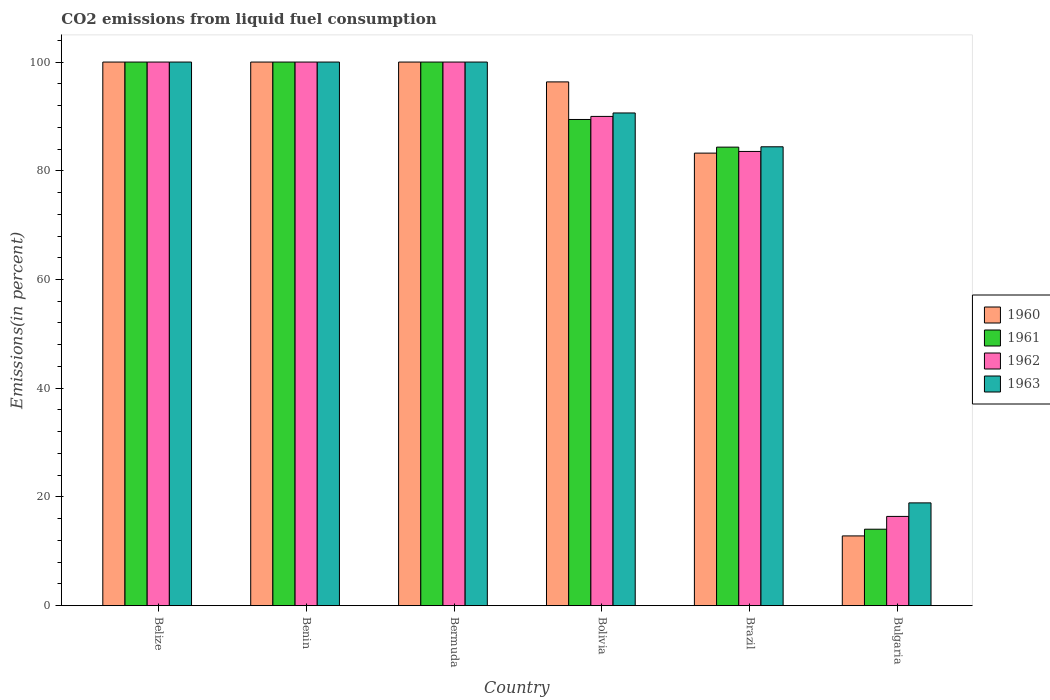How many groups of bars are there?
Keep it short and to the point. 6. Are the number of bars per tick equal to the number of legend labels?
Your answer should be very brief. Yes. Are the number of bars on each tick of the X-axis equal?
Ensure brevity in your answer.  Yes. How many bars are there on the 3rd tick from the left?
Make the answer very short. 4. In how many cases, is the number of bars for a given country not equal to the number of legend labels?
Your answer should be very brief. 0. What is the total CO2 emitted in 1960 in Bermuda?
Provide a succinct answer. 100. Across all countries, what is the minimum total CO2 emitted in 1960?
Ensure brevity in your answer.  12.83. In which country was the total CO2 emitted in 1962 maximum?
Provide a short and direct response. Belize. In which country was the total CO2 emitted in 1962 minimum?
Your answer should be compact. Bulgaria. What is the total total CO2 emitted in 1961 in the graph?
Your answer should be compact. 487.85. What is the difference between the total CO2 emitted in 1962 in Brazil and that in Bulgaria?
Ensure brevity in your answer.  67.14. What is the difference between the total CO2 emitted in 1961 in Bolivia and the total CO2 emitted in 1960 in Bermuda?
Give a very brief answer. -10.56. What is the average total CO2 emitted in 1962 per country?
Your answer should be compact. 81.66. What is the difference between the total CO2 emitted of/in 1963 and total CO2 emitted of/in 1960 in Brazil?
Your answer should be compact. 1.17. What is the ratio of the total CO2 emitted in 1960 in Benin to that in Bolivia?
Offer a terse response. 1.04. What is the difference between the highest and the lowest total CO2 emitted in 1962?
Give a very brief answer. 83.58. In how many countries, is the total CO2 emitted in 1963 greater than the average total CO2 emitted in 1963 taken over all countries?
Your response must be concise. 5. Is the sum of the total CO2 emitted in 1963 in Bolivia and Bulgaria greater than the maximum total CO2 emitted in 1960 across all countries?
Ensure brevity in your answer.  Yes. Is it the case that in every country, the sum of the total CO2 emitted in 1960 and total CO2 emitted in 1961 is greater than the sum of total CO2 emitted in 1963 and total CO2 emitted in 1962?
Offer a terse response. No. How many bars are there?
Provide a short and direct response. 24. Are the values on the major ticks of Y-axis written in scientific E-notation?
Make the answer very short. No. Does the graph contain any zero values?
Your answer should be very brief. No. Does the graph contain grids?
Provide a short and direct response. No. Where does the legend appear in the graph?
Give a very brief answer. Center right. How are the legend labels stacked?
Give a very brief answer. Vertical. What is the title of the graph?
Provide a short and direct response. CO2 emissions from liquid fuel consumption. Does "1985" appear as one of the legend labels in the graph?
Give a very brief answer. No. What is the label or title of the Y-axis?
Your answer should be very brief. Emissions(in percent). What is the Emissions(in percent) of 1961 in Belize?
Give a very brief answer. 100. What is the Emissions(in percent) of 1963 in Benin?
Your answer should be compact. 100. What is the Emissions(in percent) in 1960 in Bolivia?
Provide a succinct answer. 96.35. What is the Emissions(in percent) in 1961 in Bolivia?
Offer a terse response. 89.44. What is the Emissions(in percent) of 1963 in Bolivia?
Make the answer very short. 90.63. What is the Emissions(in percent) in 1960 in Brazil?
Keep it short and to the point. 83.25. What is the Emissions(in percent) of 1961 in Brazil?
Make the answer very short. 84.35. What is the Emissions(in percent) in 1962 in Brazil?
Your response must be concise. 83.56. What is the Emissions(in percent) of 1963 in Brazil?
Make the answer very short. 84.41. What is the Emissions(in percent) of 1960 in Bulgaria?
Give a very brief answer. 12.83. What is the Emissions(in percent) in 1961 in Bulgaria?
Offer a terse response. 14.06. What is the Emissions(in percent) of 1962 in Bulgaria?
Provide a succinct answer. 16.42. What is the Emissions(in percent) in 1963 in Bulgaria?
Keep it short and to the point. 18.9. Across all countries, what is the maximum Emissions(in percent) of 1960?
Your response must be concise. 100. Across all countries, what is the maximum Emissions(in percent) in 1961?
Your answer should be very brief. 100. Across all countries, what is the maximum Emissions(in percent) in 1963?
Your answer should be very brief. 100. Across all countries, what is the minimum Emissions(in percent) of 1960?
Your response must be concise. 12.83. Across all countries, what is the minimum Emissions(in percent) in 1961?
Provide a succinct answer. 14.06. Across all countries, what is the minimum Emissions(in percent) of 1962?
Your answer should be very brief. 16.42. Across all countries, what is the minimum Emissions(in percent) of 1963?
Offer a terse response. 18.9. What is the total Emissions(in percent) of 1960 in the graph?
Give a very brief answer. 492.43. What is the total Emissions(in percent) of 1961 in the graph?
Give a very brief answer. 487.85. What is the total Emissions(in percent) of 1962 in the graph?
Give a very brief answer. 489.97. What is the total Emissions(in percent) in 1963 in the graph?
Give a very brief answer. 493.95. What is the difference between the Emissions(in percent) in 1960 in Belize and that in Benin?
Your answer should be compact. 0. What is the difference between the Emissions(in percent) of 1961 in Belize and that in Benin?
Provide a succinct answer. 0. What is the difference between the Emissions(in percent) of 1962 in Belize and that in Benin?
Your answer should be very brief. 0. What is the difference between the Emissions(in percent) in 1963 in Belize and that in Benin?
Give a very brief answer. 0. What is the difference between the Emissions(in percent) in 1961 in Belize and that in Bermuda?
Your response must be concise. 0. What is the difference between the Emissions(in percent) in 1963 in Belize and that in Bermuda?
Provide a short and direct response. 0. What is the difference between the Emissions(in percent) in 1960 in Belize and that in Bolivia?
Provide a succinct answer. 3.65. What is the difference between the Emissions(in percent) of 1961 in Belize and that in Bolivia?
Offer a very short reply. 10.56. What is the difference between the Emissions(in percent) in 1962 in Belize and that in Bolivia?
Offer a very short reply. 10. What is the difference between the Emissions(in percent) of 1963 in Belize and that in Bolivia?
Provide a short and direct response. 9.37. What is the difference between the Emissions(in percent) in 1960 in Belize and that in Brazil?
Offer a terse response. 16.75. What is the difference between the Emissions(in percent) of 1961 in Belize and that in Brazil?
Your response must be concise. 15.65. What is the difference between the Emissions(in percent) in 1962 in Belize and that in Brazil?
Provide a short and direct response. 16.44. What is the difference between the Emissions(in percent) of 1963 in Belize and that in Brazil?
Your answer should be compact. 15.59. What is the difference between the Emissions(in percent) of 1960 in Belize and that in Bulgaria?
Offer a terse response. 87.17. What is the difference between the Emissions(in percent) of 1961 in Belize and that in Bulgaria?
Make the answer very short. 85.94. What is the difference between the Emissions(in percent) in 1962 in Belize and that in Bulgaria?
Your answer should be compact. 83.58. What is the difference between the Emissions(in percent) of 1963 in Belize and that in Bulgaria?
Make the answer very short. 81.1. What is the difference between the Emissions(in percent) of 1960 in Benin and that in Bolivia?
Provide a short and direct response. 3.65. What is the difference between the Emissions(in percent) of 1961 in Benin and that in Bolivia?
Keep it short and to the point. 10.56. What is the difference between the Emissions(in percent) of 1963 in Benin and that in Bolivia?
Your response must be concise. 9.37. What is the difference between the Emissions(in percent) of 1960 in Benin and that in Brazil?
Provide a succinct answer. 16.75. What is the difference between the Emissions(in percent) in 1961 in Benin and that in Brazil?
Offer a terse response. 15.65. What is the difference between the Emissions(in percent) of 1962 in Benin and that in Brazil?
Provide a succinct answer. 16.44. What is the difference between the Emissions(in percent) in 1963 in Benin and that in Brazil?
Ensure brevity in your answer.  15.59. What is the difference between the Emissions(in percent) of 1960 in Benin and that in Bulgaria?
Give a very brief answer. 87.17. What is the difference between the Emissions(in percent) of 1961 in Benin and that in Bulgaria?
Give a very brief answer. 85.94. What is the difference between the Emissions(in percent) of 1962 in Benin and that in Bulgaria?
Your answer should be compact. 83.58. What is the difference between the Emissions(in percent) of 1963 in Benin and that in Bulgaria?
Your answer should be very brief. 81.1. What is the difference between the Emissions(in percent) of 1960 in Bermuda and that in Bolivia?
Your answer should be very brief. 3.65. What is the difference between the Emissions(in percent) in 1961 in Bermuda and that in Bolivia?
Your answer should be compact. 10.56. What is the difference between the Emissions(in percent) in 1963 in Bermuda and that in Bolivia?
Provide a succinct answer. 9.37. What is the difference between the Emissions(in percent) in 1960 in Bermuda and that in Brazil?
Your answer should be compact. 16.75. What is the difference between the Emissions(in percent) in 1961 in Bermuda and that in Brazil?
Your answer should be compact. 15.65. What is the difference between the Emissions(in percent) of 1962 in Bermuda and that in Brazil?
Offer a very short reply. 16.44. What is the difference between the Emissions(in percent) of 1963 in Bermuda and that in Brazil?
Offer a very short reply. 15.59. What is the difference between the Emissions(in percent) of 1960 in Bermuda and that in Bulgaria?
Make the answer very short. 87.17. What is the difference between the Emissions(in percent) in 1961 in Bermuda and that in Bulgaria?
Provide a succinct answer. 85.94. What is the difference between the Emissions(in percent) of 1962 in Bermuda and that in Bulgaria?
Offer a very short reply. 83.58. What is the difference between the Emissions(in percent) of 1963 in Bermuda and that in Bulgaria?
Keep it short and to the point. 81.1. What is the difference between the Emissions(in percent) in 1960 in Bolivia and that in Brazil?
Offer a very short reply. 13.1. What is the difference between the Emissions(in percent) in 1961 in Bolivia and that in Brazil?
Provide a succinct answer. 5.09. What is the difference between the Emissions(in percent) of 1962 in Bolivia and that in Brazil?
Offer a very short reply. 6.44. What is the difference between the Emissions(in percent) of 1963 in Bolivia and that in Brazil?
Make the answer very short. 6.22. What is the difference between the Emissions(in percent) in 1960 in Bolivia and that in Bulgaria?
Give a very brief answer. 83.52. What is the difference between the Emissions(in percent) of 1961 in Bolivia and that in Bulgaria?
Keep it short and to the point. 75.37. What is the difference between the Emissions(in percent) of 1962 in Bolivia and that in Bulgaria?
Your answer should be very brief. 73.58. What is the difference between the Emissions(in percent) in 1963 in Bolivia and that in Bulgaria?
Ensure brevity in your answer.  71.73. What is the difference between the Emissions(in percent) of 1960 in Brazil and that in Bulgaria?
Make the answer very short. 70.42. What is the difference between the Emissions(in percent) of 1961 in Brazil and that in Bulgaria?
Your answer should be compact. 70.29. What is the difference between the Emissions(in percent) in 1962 in Brazil and that in Bulgaria?
Your answer should be very brief. 67.14. What is the difference between the Emissions(in percent) of 1963 in Brazil and that in Bulgaria?
Provide a short and direct response. 65.51. What is the difference between the Emissions(in percent) of 1960 in Belize and the Emissions(in percent) of 1962 in Benin?
Offer a terse response. 0. What is the difference between the Emissions(in percent) of 1960 in Belize and the Emissions(in percent) of 1963 in Benin?
Your response must be concise. 0. What is the difference between the Emissions(in percent) of 1962 in Belize and the Emissions(in percent) of 1963 in Benin?
Offer a very short reply. 0. What is the difference between the Emissions(in percent) of 1960 in Belize and the Emissions(in percent) of 1963 in Bermuda?
Your response must be concise. 0. What is the difference between the Emissions(in percent) of 1961 in Belize and the Emissions(in percent) of 1963 in Bermuda?
Offer a very short reply. 0. What is the difference between the Emissions(in percent) in 1962 in Belize and the Emissions(in percent) in 1963 in Bermuda?
Your answer should be very brief. 0. What is the difference between the Emissions(in percent) in 1960 in Belize and the Emissions(in percent) in 1961 in Bolivia?
Your response must be concise. 10.56. What is the difference between the Emissions(in percent) of 1960 in Belize and the Emissions(in percent) of 1963 in Bolivia?
Offer a terse response. 9.37. What is the difference between the Emissions(in percent) of 1961 in Belize and the Emissions(in percent) of 1963 in Bolivia?
Ensure brevity in your answer.  9.37. What is the difference between the Emissions(in percent) of 1962 in Belize and the Emissions(in percent) of 1963 in Bolivia?
Make the answer very short. 9.37. What is the difference between the Emissions(in percent) of 1960 in Belize and the Emissions(in percent) of 1961 in Brazil?
Offer a very short reply. 15.65. What is the difference between the Emissions(in percent) of 1960 in Belize and the Emissions(in percent) of 1962 in Brazil?
Your answer should be very brief. 16.44. What is the difference between the Emissions(in percent) in 1960 in Belize and the Emissions(in percent) in 1963 in Brazil?
Provide a short and direct response. 15.59. What is the difference between the Emissions(in percent) of 1961 in Belize and the Emissions(in percent) of 1962 in Brazil?
Make the answer very short. 16.44. What is the difference between the Emissions(in percent) in 1961 in Belize and the Emissions(in percent) in 1963 in Brazil?
Keep it short and to the point. 15.59. What is the difference between the Emissions(in percent) in 1962 in Belize and the Emissions(in percent) in 1963 in Brazil?
Your answer should be compact. 15.59. What is the difference between the Emissions(in percent) of 1960 in Belize and the Emissions(in percent) of 1961 in Bulgaria?
Give a very brief answer. 85.94. What is the difference between the Emissions(in percent) in 1960 in Belize and the Emissions(in percent) in 1962 in Bulgaria?
Make the answer very short. 83.58. What is the difference between the Emissions(in percent) in 1960 in Belize and the Emissions(in percent) in 1963 in Bulgaria?
Provide a succinct answer. 81.1. What is the difference between the Emissions(in percent) in 1961 in Belize and the Emissions(in percent) in 1962 in Bulgaria?
Ensure brevity in your answer.  83.58. What is the difference between the Emissions(in percent) of 1961 in Belize and the Emissions(in percent) of 1963 in Bulgaria?
Provide a short and direct response. 81.1. What is the difference between the Emissions(in percent) of 1962 in Belize and the Emissions(in percent) of 1963 in Bulgaria?
Your answer should be very brief. 81.1. What is the difference between the Emissions(in percent) in 1960 in Benin and the Emissions(in percent) in 1961 in Bermuda?
Your answer should be very brief. 0. What is the difference between the Emissions(in percent) in 1960 in Benin and the Emissions(in percent) in 1962 in Bermuda?
Your response must be concise. 0. What is the difference between the Emissions(in percent) in 1960 in Benin and the Emissions(in percent) in 1963 in Bermuda?
Offer a very short reply. 0. What is the difference between the Emissions(in percent) of 1961 in Benin and the Emissions(in percent) of 1963 in Bermuda?
Keep it short and to the point. 0. What is the difference between the Emissions(in percent) in 1960 in Benin and the Emissions(in percent) in 1961 in Bolivia?
Provide a short and direct response. 10.56. What is the difference between the Emissions(in percent) in 1960 in Benin and the Emissions(in percent) in 1963 in Bolivia?
Give a very brief answer. 9.37. What is the difference between the Emissions(in percent) of 1961 in Benin and the Emissions(in percent) of 1962 in Bolivia?
Provide a short and direct response. 10. What is the difference between the Emissions(in percent) in 1961 in Benin and the Emissions(in percent) in 1963 in Bolivia?
Give a very brief answer. 9.37. What is the difference between the Emissions(in percent) in 1962 in Benin and the Emissions(in percent) in 1963 in Bolivia?
Offer a very short reply. 9.37. What is the difference between the Emissions(in percent) in 1960 in Benin and the Emissions(in percent) in 1961 in Brazil?
Your answer should be very brief. 15.65. What is the difference between the Emissions(in percent) of 1960 in Benin and the Emissions(in percent) of 1962 in Brazil?
Make the answer very short. 16.44. What is the difference between the Emissions(in percent) of 1960 in Benin and the Emissions(in percent) of 1963 in Brazil?
Offer a terse response. 15.59. What is the difference between the Emissions(in percent) in 1961 in Benin and the Emissions(in percent) in 1962 in Brazil?
Give a very brief answer. 16.44. What is the difference between the Emissions(in percent) of 1961 in Benin and the Emissions(in percent) of 1963 in Brazil?
Provide a short and direct response. 15.59. What is the difference between the Emissions(in percent) in 1962 in Benin and the Emissions(in percent) in 1963 in Brazil?
Your response must be concise. 15.59. What is the difference between the Emissions(in percent) in 1960 in Benin and the Emissions(in percent) in 1961 in Bulgaria?
Ensure brevity in your answer.  85.94. What is the difference between the Emissions(in percent) in 1960 in Benin and the Emissions(in percent) in 1962 in Bulgaria?
Your response must be concise. 83.58. What is the difference between the Emissions(in percent) in 1960 in Benin and the Emissions(in percent) in 1963 in Bulgaria?
Your answer should be compact. 81.1. What is the difference between the Emissions(in percent) in 1961 in Benin and the Emissions(in percent) in 1962 in Bulgaria?
Keep it short and to the point. 83.58. What is the difference between the Emissions(in percent) of 1961 in Benin and the Emissions(in percent) of 1963 in Bulgaria?
Offer a terse response. 81.1. What is the difference between the Emissions(in percent) in 1962 in Benin and the Emissions(in percent) in 1963 in Bulgaria?
Provide a succinct answer. 81.1. What is the difference between the Emissions(in percent) of 1960 in Bermuda and the Emissions(in percent) of 1961 in Bolivia?
Provide a succinct answer. 10.56. What is the difference between the Emissions(in percent) of 1960 in Bermuda and the Emissions(in percent) of 1963 in Bolivia?
Ensure brevity in your answer.  9.37. What is the difference between the Emissions(in percent) of 1961 in Bermuda and the Emissions(in percent) of 1963 in Bolivia?
Your answer should be compact. 9.37. What is the difference between the Emissions(in percent) of 1962 in Bermuda and the Emissions(in percent) of 1963 in Bolivia?
Your answer should be very brief. 9.37. What is the difference between the Emissions(in percent) of 1960 in Bermuda and the Emissions(in percent) of 1961 in Brazil?
Give a very brief answer. 15.65. What is the difference between the Emissions(in percent) of 1960 in Bermuda and the Emissions(in percent) of 1962 in Brazil?
Your response must be concise. 16.44. What is the difference between the Emissions(in percent) of 1960 in Bermuda and the Emissions(in percent) of 1963 in Brazil?
Ensure brevity in your answer.  15.59. What is the difference between the Emissions(in percent) in 1961 in Bermuda and the Emissions(in percent) in 1962 in Brazil?
Make the answer very short. 16.44. What is the difference between the Emissions(in percent) in 1961 in Bermuda and the Emissions(in percent) in 1963 in Brazil?
Your answer should be compact. 15.59. What is the difference between the Emissions(in percent) of 1962 in Bermuda and the Emissions(in percent) of 1963 in Brazil?
Offer a very short reply. 15.59. What is the difference between the Emissions(in percent) in 1960 in Bermuda and the Emissions(in percent) in 1961 in Bulgaria?
Provide a short and direct response. 85.94. What is the difference between the Emissions(in percent) in 1960 in Bermuda and the Emissions(in percent) in 1962 in Bulgaria?
Keep it short and to the point. 83.58. What is the difference between the Emissions(in percent) of 1960 in Bermuda and the Emissions(in percent) of 1963 in Bulgaria?
Provide a short and direct response. 81.1. What is the difference between the Emissions(in percent) of 1961 in Bermuda and the Emissions(in percent) of 1962 in Bulgaria?
Offer a very short reply. 83.58. What is the difference between the Emissions(in percent) in 1961 in Bermuda and the Emissions(in percent) in 1963 in Bulgaria?
Provide a short and direct response. 81.1. What is the difference between the Emissions(in percent) of 1962 in Bermuda and the Emissions(in percent) of 1963 in Bulgaria?
Offer a very short reply. 81.1. What is the difference between the Emissions(in percent) of 1960 in Bolivia and the Emissions(in percent) of 1961 in Brazil?
Provide a succinct answer. 12. What is the difference between the Emissions(in percent) of 1960 in Bolivia and the Emissions(in percent) of 1962 in Brazil?
Your answer should be very brief. 12.8. What is the difference between the Emissions(in percent) in 1960 in Bolivia and the Emissions(in percent) in 1963 in Brazil?
Ensure brevity in your answer.  11.94. What is the difference between the Emissions(in percent) of 1961 in Bolivia and the Emissions(in percent) of 1962 in Brazil?
Your answer should be very brief. 5.88. What is the difference between the Emissions(in percent) in 1961 in Bolivia and the Emissions(in percent) in 1963 in Brazil?
Give a very brief answer. 5.02. What is the difference between the Emissions(in percent) of 1962 in Bolivia and the Emissions(in percent) of 1963 in Brazil?
Your answer should be very brief. 5.59. What is the difference between the Emissions(in percent) in 1960 in Bolivia and the Emissions(in percent) in 1961 in Bulgaria?
Your answer should be very brief. 82.29. What is the difference between the Emissions(in percent) in 1960 in Bolivia and the Emissions(in percent) in 1962 in Bulgaria?
Give a very brief answer. 79.93. What is the difference between the Emissions(in percent) of 1960 in Bolivia and the Emissions(in percent) of 1963 in Bulgaria?
Your response must be concise. 77.45. What is the difference between the Emissions(in percent) of 1961 in Bolivia and the Emissions(in percent) of 1962 in Bulgaria?
Keep it short and to the point. 73.02. What is the difference between the Emissions(in percent) of 1961 in Bolivia and the Emissions(in percent) of 1963 in Bulgaria?
Ensure brevity in your answer.  70.53. What is the difference between the Emissions(in percent) in 1962 in Bolivia and the Emissions(in percent) in 1963 in Bulgaria?
Keep it short and to the point. 71.1. What is the difference between the Emissions(in percent) in 1960 in Brazil and the Emissions(in percent) in 1961 in Bulgaria?
Provide a succinct answer. 69.19. What is the difference between the Emissions(in percent) in 1960 in Brazil and the Emissions(in percent) in 1962 in Bulgaria?
Make the answer very short. 66.83. What is the difference between the Emissions(in percent) in 1960 in Brazil and the Emissions(in percent) in 1963 in Bulgaria?
Make the answer very short. 64.34. What is the difference between the Emissions(in percent) of 1961 in Brazil and the Emissions(in percent) of 1962 in Bulgaria?
Your answer should be very brief. 67.93. What is the difference between the Emissions(in percent) in 1961 in Brazil and the Emissions(in percent) in 1963 in Bulgaria?
Provide a short and direct response. 65.44. What is the difference between the Emissions(in percent) of 1962 in Brazil and the Emissions(in percent) of 1963 in Bulgaria?
Offer a very short reply. 64.65. What is the average Emissions(in percent) in 1960 per country?
Your response must be concise. 82.07. What is the average Emissions(in percent) in 1961 per country?
Provide a succinct answer. 81.31. What is the average Emissions(in percent) of 1962 per country?
Your response must be concise. 81.66. What is the average Emissions(in percent) in 1963 per country?
Provide a short and direct response. 82.33. What is the difference between the Emissions(in percent) in 1960 and Emissions(in percent) in 1963 in Belize?
Your response must be concise. 0. What is the difference between the Emissions(in percent) of 1961 and Emissions(in percent) of 1963 in Belize?
Offer a very short reply. 0. What is the difference between the Emissions(in percent) of 1962 and Emissions(in percent) of 1963 in Belize?
Make the answer very short. 0. What is the difference between the Emissions(in percent) of 1960 and Emissions(in percent) of 1961 in Benin?
Your answer should be compact. 0. What is the difference between the Emissions(in percent) of 1960 and Emissions(in percent) of 1962 in Benin?
Your response must be concise. 0. What is the difference between the Emissions(in percent) of 1960 and Emissions(in percent) of 1963 in Benin?
Provide a succinct answer. 0. What is the difference between the Emissions(in percent) in 1961 and Emissions(in percent) in 1962 in Benin?
Ensure brevity in your answer.  0. What is the difference between the Emissions(in percent) in 1961 and Emissions(in percent) in 1963 in Benin?
Offer a very short reply. 0. What is the difference between the Emissions(in percent) of 1960 and Emissions(in percent) of 1962 in Bermuda?
Provide a short and direct response. 0. What is the difference between the Emissions(in percent) in 1960 and Emissions(in percent) in 1963 in Bermuda?
Provide a short and direct response. 0. What is the difference between the Emissions(in percent) of 1961 and Emissions(in percent) of 1962 in Bermuda?
Provide a short and direct response. 0. What is the difference between the Emissions(in percent) of 1962 and Emissions(in percent) of 1963 in Bermuda?
Ensure brevity in your answer.  0. What is the difference between the Emissions(in percent) in 1960 and Emissions(in percent) in 1961 in Bolivia?
Provide a short and direct response. 6.91. What is the difference between the Emissions(in percent) in 1960 and Emissions(in percent) in 1962 in Bolivia?
Your response must be concise. 6.35. What is the difference between the Emissions(in percent) of 1960 and Emissions(in percent) of 1963 in Bolivia?
Your answer should be compact. 5.72. What is the difference between the Emissions(in percent) of 1961 and Emissions(in percent) of 1962 in Bolivia?
Your answer should be compact. -0.56. What is the difference between the Emissions(in percent) of 1961 and Emissions(in percent) of 1963 in Bolivia?
Your answer should be very brief. -1.2. What is the difference between the Emissions(in percent) of 1962 and Emissions(in percent) of 1963 in Bolivia?
Keep it short and to the point. -0.63. What is the difference between the Emissions(in percent) of 1960 and Emissions(in percent) of 1961 in Brazil?
Offer a very short reply. -1.1. What is the difference between the Emissions(in percent) in 1960 and Emissions(in percent) in 1962 in Brazil?
Make the answer very short. -0.31. What is the difference between the Emissions(in percent) in 1960 and Emissions(in percent) in 1963 in Brazil?
Your response must be concise. -1.17. What is the difference between the Emissions(in percent) in 1961 and Emissions(in percent) in 1962 in Brazil?
Provide a short and direct response. 0.79. What is the difference between the Emissions(in percent) of 1961 and Emissions(in percent) of 1963 in Brazil?
Offer a very short reply. -0.06. What is the difference between the Emissions(in percent) of 1962 and Emissions(in percent) of 1963 in Brazil?
Provide a succinct answer. -0.86. What is the difference between the Emissions(in percent) of 1960 and Emissions(in percent) of 1961 in Bulgaria?
Offer a terse response. -1.23. What is the difference between the Emissions(in percent) in 1960 and Emissions(in percent) in 1962 in Bulgaria?
Give a very brief answer. -3.59. What is the difference between the Emissions(in percent) in 1960 and Emissions(in percent) in 1963 in Bulgaria?
Provide a succinct answer. -6.08. What is the difference between the Emissions(in percent) of 1961 and Emissions(in percent) of 1962 in Bulgaria?
Keep it short and to the point. -2.35. What is the difference between the Emissions(in percent) in 1961 and Emissions(in percent) in 1963 in Bulgaria?
Your answer should be compact. -4.84. What is the difference between the Emissions(in percent) of 1962 and Emissions(in percent) of 1963 in Bulgaria?
Ensure brevity in your answer.  -2.49. What is the ratio of the Emissions(in percent) of 1960 in Belize to that in Benin?
Give a very brief answer. 1. What is the ratio of the Emissions(in percent) in 1961 in Belize to that in Benin?
Your response must be concise. 1. What is the ratio of the Emissions(in percent) in 1960 in Belize to that in Bermuda?
Keep it short and to the point. 1. What is the ratio of the Emissions(in percent) in 1963 in Belize to that in Bermuda?
Keep it short and to the point. 1. What is the ratio of the Emissions(in percent) of 1960 in Belize to that in Bolivia?
Give a very brief answer. 1.04. What is the ratio of the Emissions(in percent) in 1961 in Belize to that in Bolivia?
Offer a terse response. 1.12. What is the ratio of the Emissions(in percent) in 1962 in Belize to that in Bolivia?
Your answer should be very brief. 1.11. What is the ratio of the Emissions(in percent) in 1963 in Belize to that in Bolivia?
Your response must be concise. 1.1. What is the ratio of the Emissions(in percent) in 1960 in Belize to that in Brazil?
Your response must be concise. 1.2. What is the ratio of the Emissions(in percent) of 1961 in Belize to that in Brazil?
Offer a terse response. 1.19. What is the ratio of the Emissions(in percent) in 1962 in Belize to that in Brazil?
Offer a terse response. 1.2. What is the ratio of the Emissions(in percent) in 1963 in Belize to that in Brazil?
Your answer should be very brief. 1.18. What is the ratio of the Emissions(in percent) in 1960 in Belize to that in Bulgaria?
Ensure brevity in your answer.  7.79. What is the ratio of the Emissions(in percent) in 1961 in Belize to that in Bulgaria?
Keep it short and to the point. 7.11. What is the ratio of the Emissions(in percent) of 1962 in Belize to that in Bulgaria?
Give a very brief answer. 6.09. What is the ratio of the Emissions(in percent) in 1963 in Belize to that in Bulgaria?
Keep it short and to the point. 5.29. What is the ratio of the Emissions(in percent) of 1961 in Benin to that in Bermuda?
Provide a succinct answer. 1. What is the ratio of the Emissions(in percent) of 1962 in Benin to that in Bermuda?
Your response must be concise. 1. What is the ratio of the Emissions(in percent) in 1963 in Benin to that in Bermuda?
Provide a succinct answer. 1. What is the ratio of the Emissions(in percent) in 1960 in Benin to that in Bolivia?
Give a very brief answer. 1.04. What is the ratio of the Emissions(in percent) of 1961 in Benin to that in Bolivia?
Your answer should be very brief. 1.12. What is the ratio of the Emissions(in percent) of 1962 in Benin to that in Bolivia?
Offer a very short reply. 1.11. What is the ratio of the Emissions(in percent) of 1963 in Benin to that in Bolivia?
Provide a short and direct response. 1.1. What is the ratio of the Emissions(in percent) of 1960 in Benin to that in Brazil?
Keep it short and to the point. 1.2. What is the ratio of the Emissions(in percent) in 1961 in Benin to that in Brazil?
Ensure brevity in your answer.  1.19. What is the ratio of the Emissions(in percent) in 1962 in Benin to that in Brazil?
Offer a very short reply. 1.2. What is the ratio of the Emissions(in percent) in 1963 in Benin to that in Brazil?
Offer a very short reply. 1.18. What is the ratio of the Emissions(in percent) of 1960 in Benin to that in Bulgaria?
Your response must be concise. 7.79. What is the ratio of the Emissions(in percent) of 1961 in Benin to that in Bulgaria?
Your answer should be very brief. 7.11. What is the ratio of the Emissions(in percent) in 1962 in Benin to that in Bulgaria?
Make the answer very short. 6.09. What is the ratio of the Emissions(in percent) of 1963 in Benin to that in Bulgaria?
Your response must be concise. 5.29. What is the ratio of the Emissions(in percent) in 1960 in Bermuda to that in Bolivia?
Offer a terse response. 1.04. What is the ratio of the Emissions(in percent) in 1961 in Bermuda to that in Bolivia?
Provide a succinct answer. 1.12. What is the ratio of the Emissions(in percent) of 1962 in Bermuda to that in Bolivia?
Make the answer very short. 1.11. What is the ratio of the Emissions(in percent) of 1963 in Bermuda to that in Bolivia?
Make the answer very short. 1.1. What is the ratio of the Emissions(in percent) in 1960 in Bermuda to that in Brazil?
Your response must be concise. 1.2. What is the ratio of the Emissions(in percent) of 1961 in Bermuda to that in Brazil?
Ensure brevity in your answer.  1.19. What is the ratio of the Emissions(in percent) of 1962 in Bermuda to that in Brazil?
Give a very brief answer. 1.2. What is the ratio of the Emissions(in percent) of 1963 in Bermuda to that in Brazil?
Keep it short and to the point. 1.18. What is the ratio of the Emissions(in percent) of 1960 in Bermuda to that in Bulgaria?
Ensure brevity in your answer.  7.79. What is the ratio of the Emissions(in percent) in 1961 in Bermuda to that in Bulgaria?
Keep it short and to the point. 7.11. What is the ratio of the Emissions(in percent) of 1962 in Bermuda to that in Bulgaria?
Provide a short and direct response. 6.09. What is the ratio of the Emissions(in percent) of 1963 in Bermuda to that in Bulgaria?
Provide a short and direct response. 5.29. What is the ratio of the Emissions(in percent) in 1960 in Bolivia to that in Brazil?
Provide a short and direct response. 1.16. What is the ratio of the Emissions(in percent) of 1961 in Bolivia to that in Brazil?
Your answer should be very brief. 1.06. What is the ratio of the Emissions(in percent) in 1962 in Bolivia to that in Brazil?
Give a very brief answer. 1.08. What is the ratio of the Emissions(in percent) of 1963 in Bolivia to that in Brazil?
Give a very brief answer. 1.07. What is the ratio of the Emissions(in percent) in 1960 in Bolivia to that in Bulgaria?
Provide a short and direct response. 7.51. What is the ratio of the Emissions(in percent) in 1961 in Bolivia to that in Bulgaria?
Your answer should be very brief. 6.36. What is the ratio of the Emissions(in percent) of 1962 in Bolivia to that in Bulgaria?
Provide a succinct answer. 5.48. What is the ratio of the Emissions(in percent) in 1963 in Bolivia to that in Bulgaria?
Your answer should be very brief. 4.79. What is the ratio of the Emissions(in percent) in 1960 in Brazil to that in Bulgaria?
Offer a very short reply. 6.49. What is the ratio of the Emissions(in percent) in 1961 in Brazil to that in Bulgaria?
Keep it short and to the point. 6. What is the ratio of the Emissions(in percent) in 1962 in Brazil to that in Bulgaria?
Your response must be concise. 5.09. What is the ratio of the Emissions(in percent) in 1963 in Brazil to that in Bulgaria?
Provide a short and direct response. 4.47. What is the difference between the highest and the second highest Emissions(in percent) of 1963?
Provide a short and direct response. 0. What is the difference between the highest and the lowest Emissions(in percent) of 1960?
Offer a very short reply. 87.17. What is the difference between the highest and the lowest Emissions(in percent) of 1961?
Give a very brief answer. 85.94. What is the difference between the highest and the lowest Emissions(in percent) of 1962?
Ensure brevity in your answer.  83.58. What is the difference between the highest and the lowest Emissions(in percent) of 1963?
Provide a succinct answer. 81.1. 